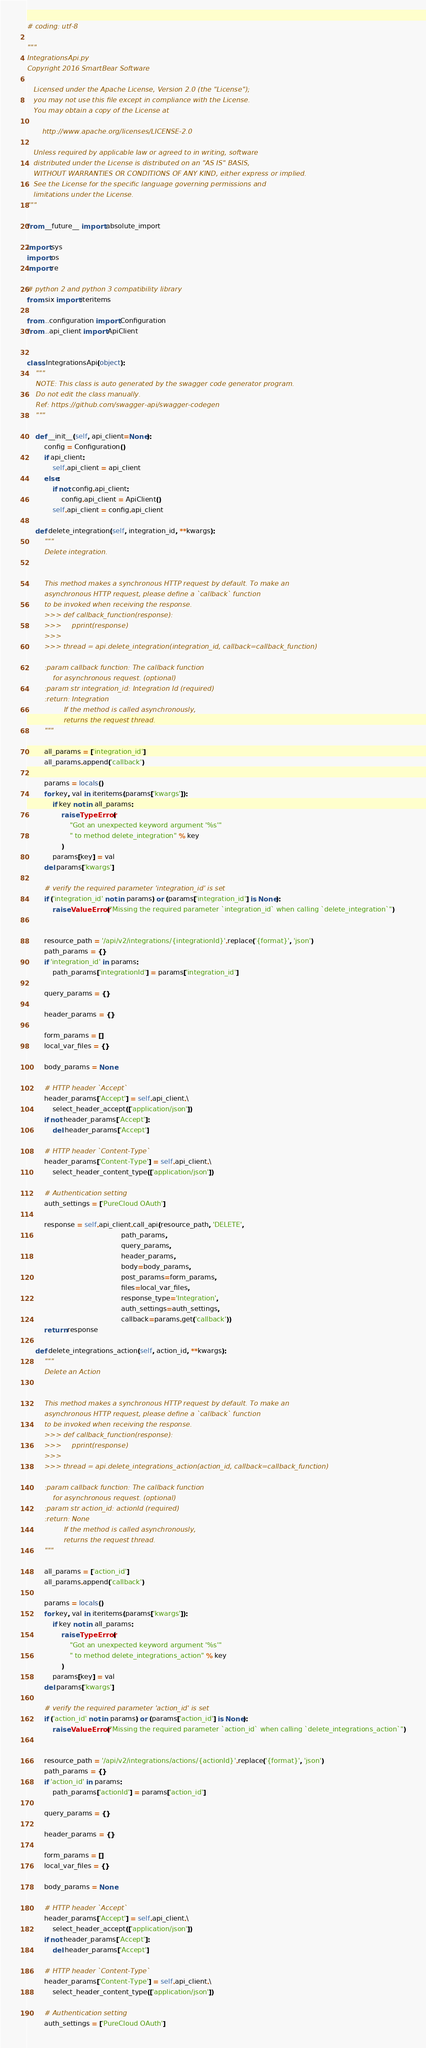<code> <loc_0><loc_0><loc_500><loc_500><_Python_># coding: utf-8

"""
IntegrationsApi.py
Copyright 2016 SmartBear Software

   Licensed under the Apache License, Version 2.0 (the "License");
   you may not use this file except in compliance with the License.
   You may obtain a copy of the License at

       http://www.apache.org/licenses/LICENSE-2.0

   Unless required by applicable law or agreed to in writing, software
   distributed under the License is distributed on an "AS IS" BASIS,
   WITHOUT WARRANTIES OR CONDITIONS OF ANY KIND, either express or implied.
   See the License for the specific language governing permissions and
   limitations under the License.
"""

from __future__ import absolute_import

import sys
import os
import re

# python 2 and python 3 compatibility library
from six import iteritems

from ..configuration import Configuration
from ..api_client import ApiClient


class IntegrationsApi(object):
    """
    NOTE: This class is auto generated by the swagger code generator program.
    Do not edit the class manually.
    Ref: https://github.com/swagger-api/swagger-codegen
    """

    def __init__(self, api_client=None):
        config = Configuration()
        if api_client:
            self.api_client = api_client
        else:
            if not config.api_client:
                config.api_client = ApiClient()
            self.api_client = config.api_client

    def delete_integration(self, integration_id, **kwargs):
        """
        Delete integration.
        

        This method makes a synchronous HTTP request by default. To make an
        asynchronous HTTP request, please define a `callback` function
        to be invoked when receiving the response.
        >>> def callback_function(response):
        >>>     pprint(response)
        >>>
        >>> thread = api.delete_integration(integration_id, callback=callback_function)

        :param callback function: The callback function
            for asynchronous request. (optional)
        :param str integration_id: Integration Id (required)
        :return: Integration
                 If the method is called asynchronously,
                 returns the request thread.
        """

        all_params = ['integration_id']
        all_params.append('callback')

        params = locals()
        for key, val in iteritems(params['kwargs']):
            if key not in all_params:
                raise TypeError(
                    "Got an unexpected keyword argument '%s'"
                    " to method delete_integration" % key
                )
            params[key] = val
        del params['kwargs']

        # verify the required parameter 'integration_id' is set
        if ('integration_id' not in params) or (params['integration_id'] is None):
            raise ValueError("Missing the required parameter `integration_id` when calling `delete_integration`")


        resource_path = '/api/v2/integrations/{integrationId}'.replace('{format}', 'json')
        path_params = {}
        if 'integration_id' in params:
            path_params['integrationId'] = params['integration_id']

        query_params = {}

        header_params = {}

        form_params = []
        local_var_files = {}

        body_params = None

        # HTTP header `Accept`
        header_params['Accept'] = self.api_client.\
            select_header_accept(['application/json'])
        if not header_params['Accept']:
            del header_params['Accept']

        # HTTP header `Content-Type`
        header_params['Content-Type'] = self.api_client.\
            select_header_content_type(['application/json'])

        # Authentication setting
        auth_settings = ['PureCloud OAuth']

        response = self.api_client.call_api(resource_path, 'DELETE',
                                            path_params,
                                            query_params,
                                            header_params,
                                            body=body_params,
                                            post_params=form_params,
                                            files=local_var_files,
                                            response_type='Integration',
                                            auth_settings=auth_settings,
                                            callback=params.get('callback'))
        return response

    def delete_integrations_action(self, action_id, **kwargs):
        """
        Delete an Action
        

        This method makes a synchronous HTTP request by default. To make an
        asynchronous HTTP request, please define a `callback` function
        to be invoked when receiving the response.
        >>> def callback_function(response):
        >>>     pprint(response)
        >>>
        >>> thread = api.delete_integrations_action(action_id, callback=callback_function)

        :param callback function: The callback function
            for asynchronous request. (optional)
        :param str action_id: actionId (required)
        :return: None
                 If the method is called asynchronously,
                 returns the request thread.
        """

        all_params = ['action_id']
        all_params.append('callback')

        params = locals()
        for key, val in iteritems(params['kwargs']):
            if key not in all_params:
                raise TypeError(
                    "Got an unexpected keyword argument '%s'"
                    " to method delete_integrations_action" % key
                )
            params[key] = val
        del params['kwargs']

        # verify the required parameter 'action_id' is set
        if ('action_id' not in params) or (params['action_id'] is None):
            raise ValueError("Missing the required parameter `action_id` when calling `delete_integrations_action`")


        resource_path = '/api/v2/integrations/actions/{actionId}'.replace('{format}', 'json')
        path_params = {}
        if 'action_id' in params:
            path_params['actionId'] = params['action_id']

        query_params = {}

        header_params = {}

        form_params = []
        local_var_files = {}

        body_params = None

        # HTTP header `Accept`
        header_params['Accept'] = self.api_client.\
            select_header_accept(['application/json'])
        if not header_params['Accept']:
            del header_params['Accept']

        # HTTP header `Content-Type`
        header_params['Content-Type'] = self.api_client.\
            select_header_content_type(['application/json'])

        # Authentication setting
        auth_settings = ['PureCloud OAuth']
</code> 